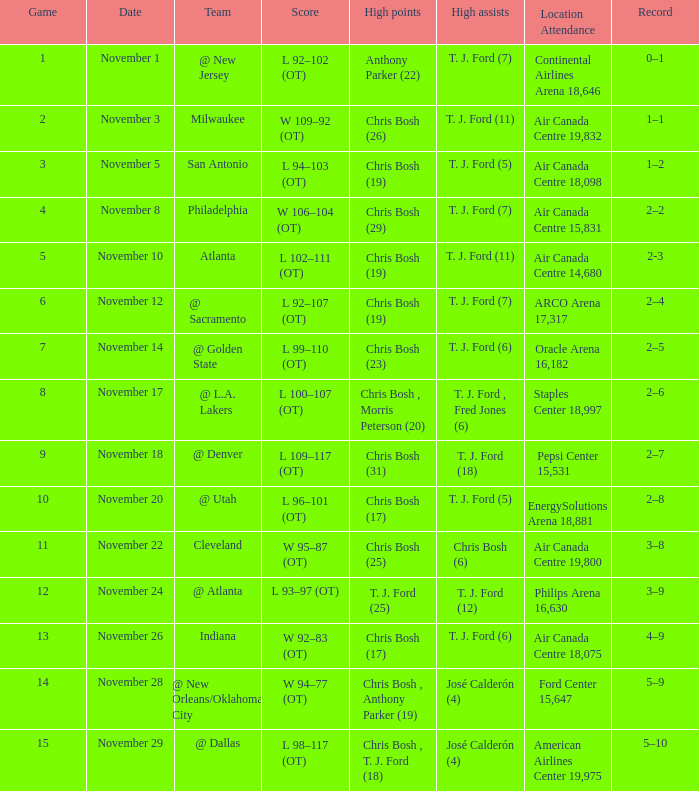What group competed on november 28? @ New Orleans/Oklahoma City. 